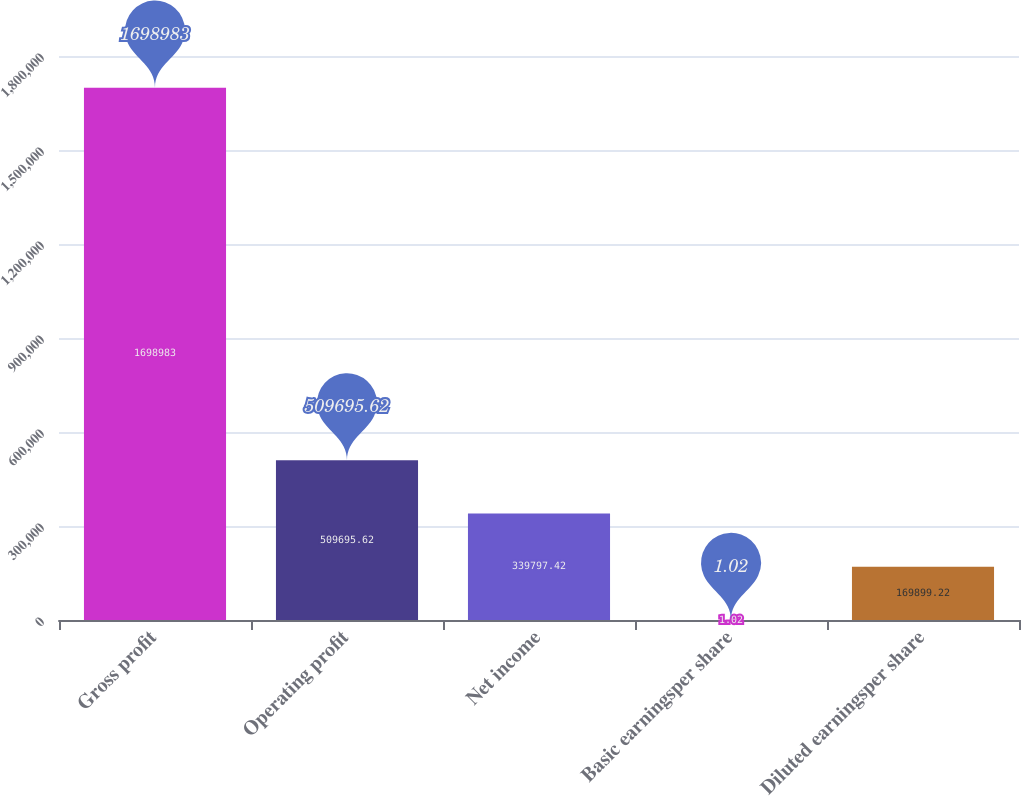Convert chart. <chart><loc_0><loc_0><loc_500><loc_500><bar_chart><fcel>Gross profit<fcel>Operating profit<fcel>Net income<fcel>Basic earningsper share<fcel>Diluted earningsper share<nl><fcel>1.69898e+06<fcel>509696<fcel>339797<fcel>1.02<fcel>169899<nl></chart> 